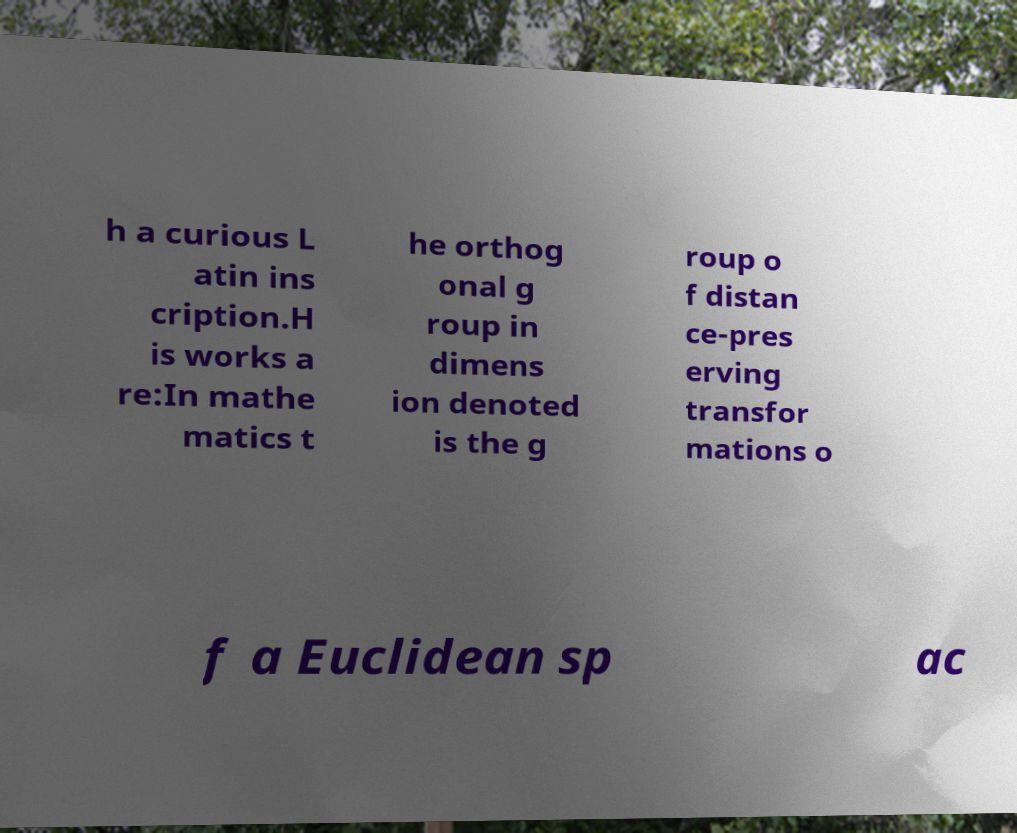Could you assist in decoding the text presented in this image and type it out clearly? h a curious L atin ins cription.H is works a re:In mathe matics t he orthog onal g roup in dimens ion denoted is the g roup o f distan ce-pres erving transfor mations o f a Euclidean sp ac 